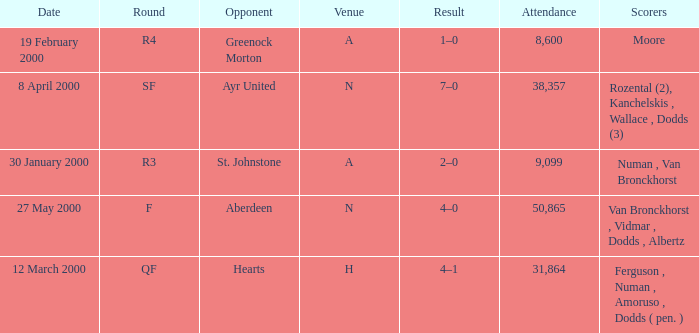Who was on 12 March 2000? Ferguson , Numan , Amoruso , Dodds ( pen. ). 